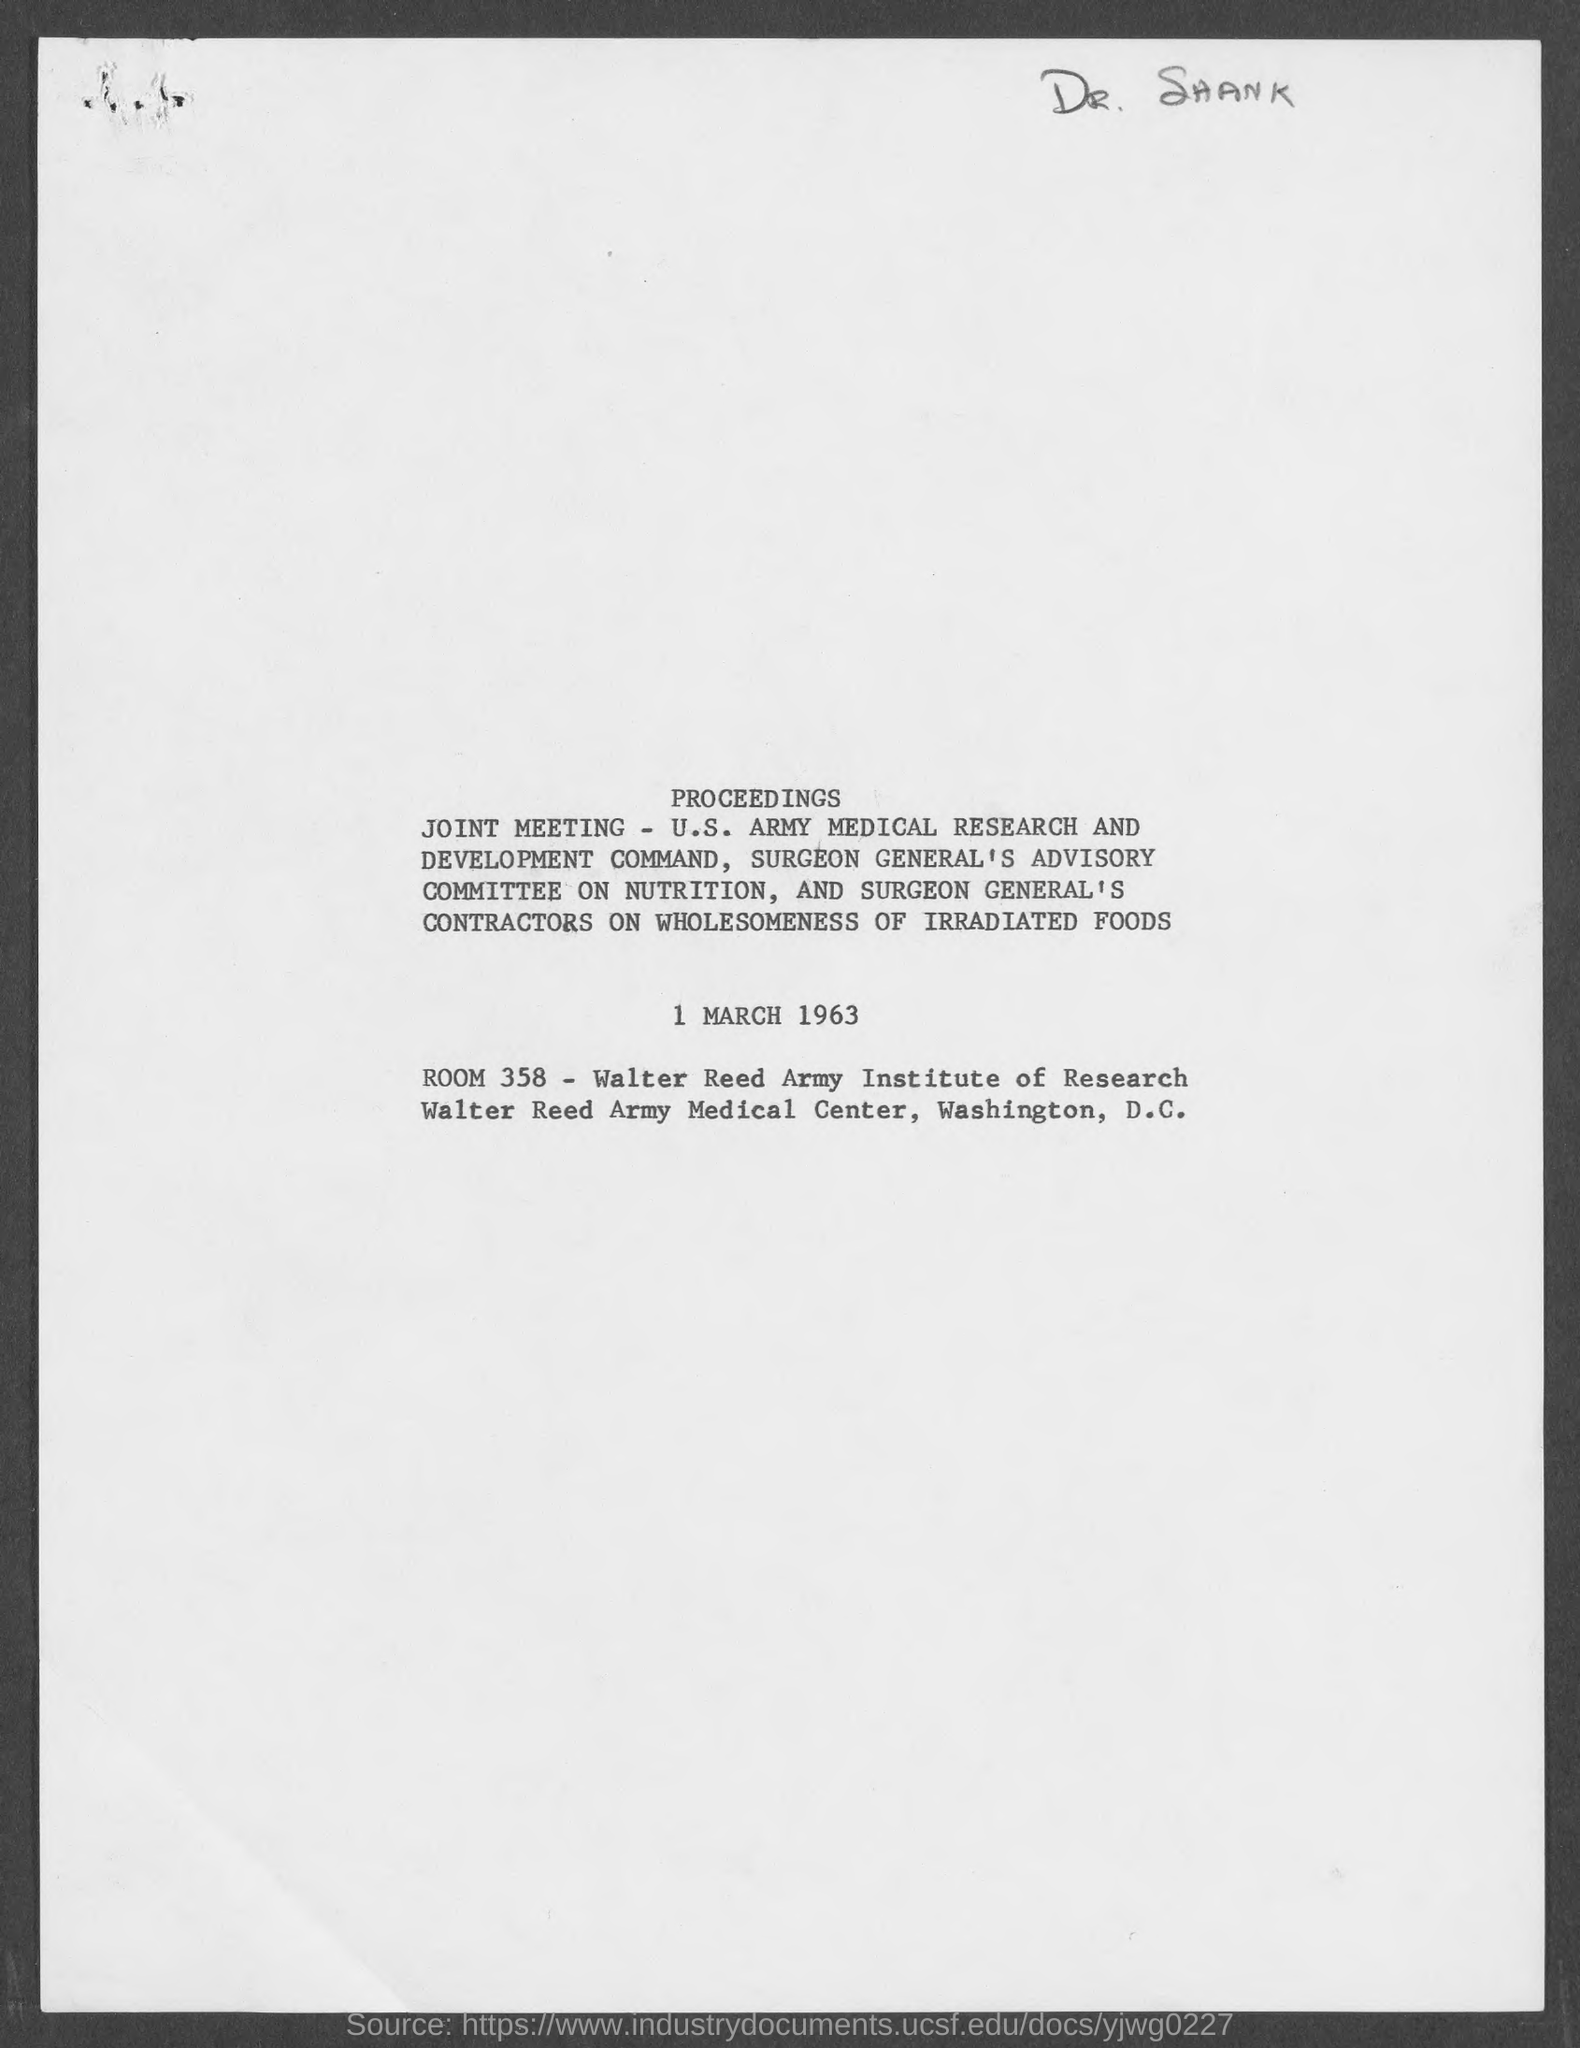What is the date?
Keep it short and to the point. 1 MARCH 1963. What is the ROOM?
Offer a very short reply. 358. 